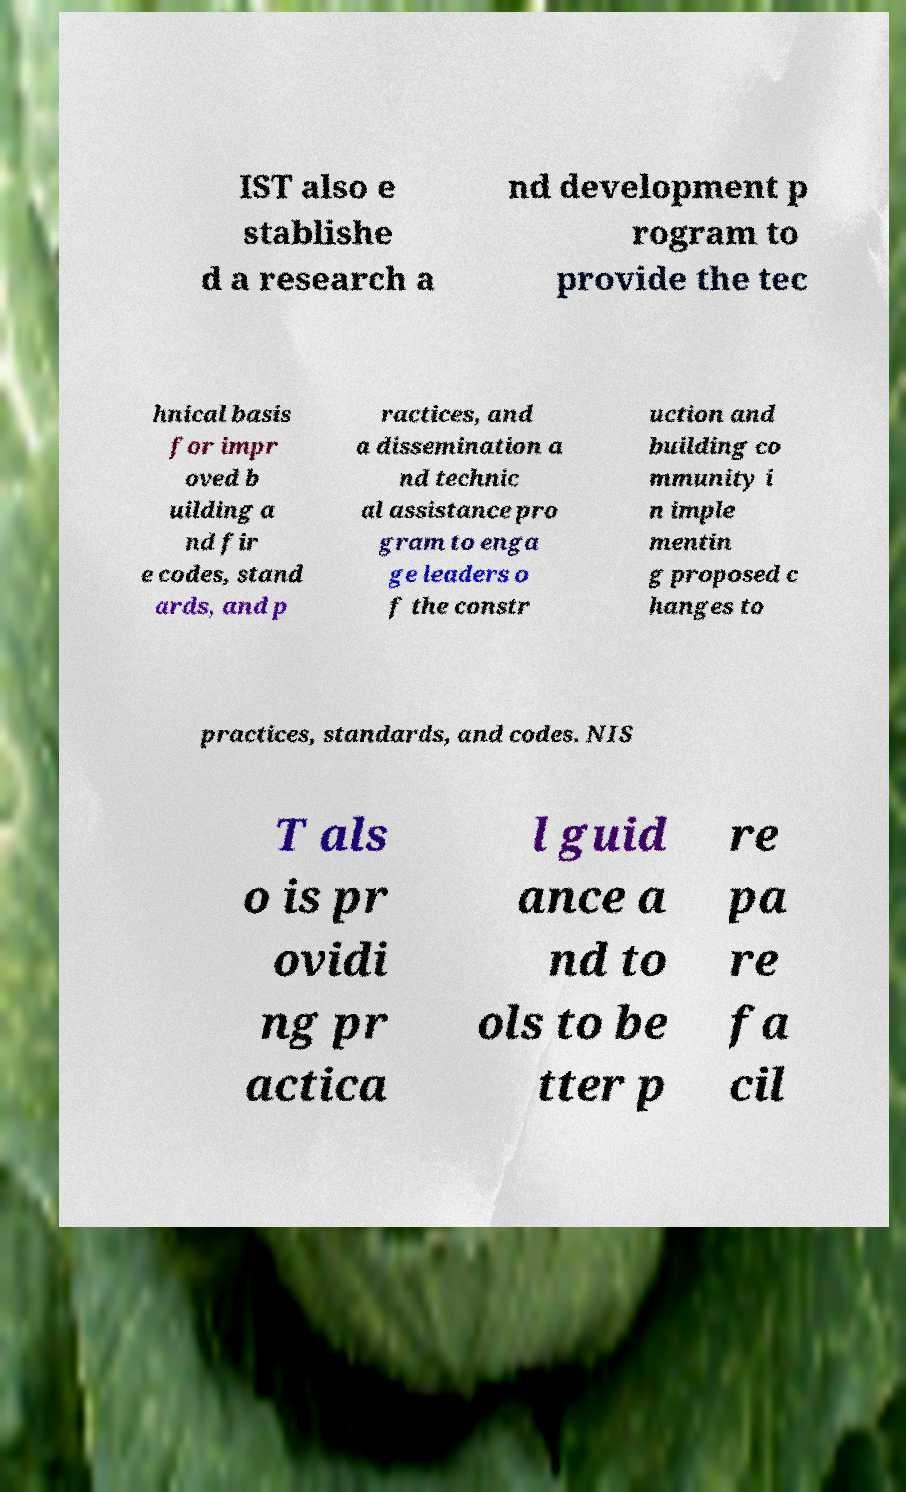Can you read and provide the text displayed in the image?This photo seems to have some interesting text. Can you extract and type it out for me? IST also e stablishe d a research a nd development p rogram to provide the tec hnical basis for impr oved b uilding a nd fir e codes, stand ards, and p ractices, and a dissemination a nd technic al assistance pro gram to enga ge leaders o f the constr uction and building co mmunity i n imple mentin g proposed c hanges to practices, standards, and codes. NIS T als o is pr ovidi ng pr actica l guid ance a nd to ols to be tter p re pa re fa cil 